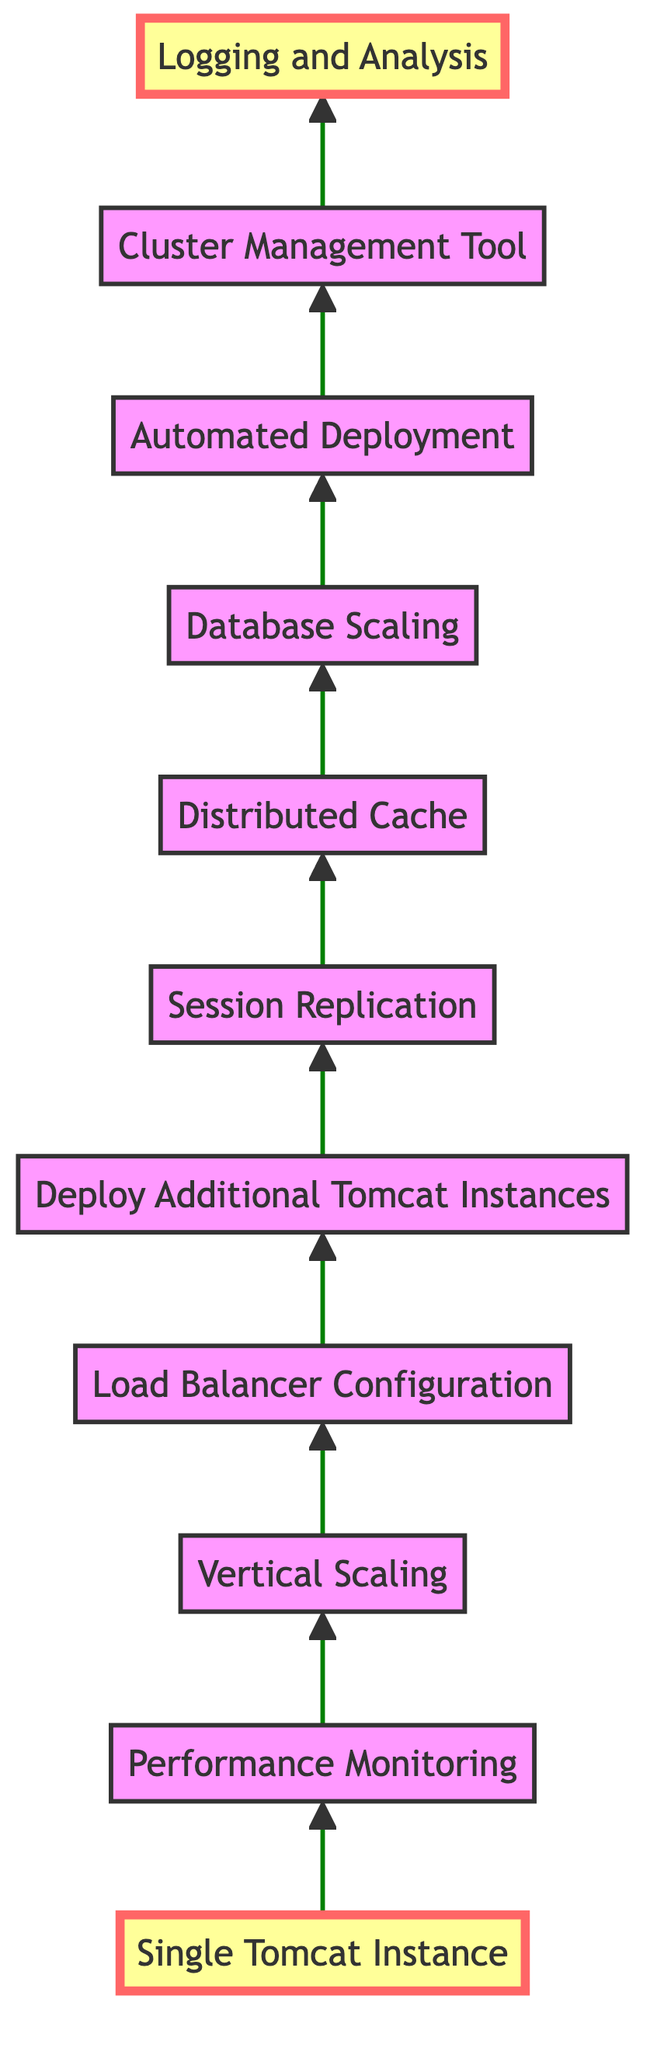What's the first step in scaling a Tomcat server? The diagram starts with a single instance, which is labeled as "Single Tomcat Instance." This is the foundation from where scaling begins.
Answer: Single Tomcat Instance How many nodes are in the diagram? The diagram contains a total of eleven nodes, each representing a step in the scaling process from a single Tomcat instance to a clustered environment.
Answer: Eleven What is the last step in the scaling process? The last node at the top of the diagram is "Logging and Analysis," which is the final step after implementing all other scaling measures.
Answer: Logging and Analysis How does "Load Balancer Configuration" relate to "Deploy Additional Tomcat Instances"? The diagram shows a direct progression from "Load Balancer Configuration" to "Deploy Additional Tomcat Instances," indicating that configuring a load balancer is necessary before deploying additional instances to handle distributed traffic.
Answer: It is a prerequisite Which step emphasizes enhancing the server's hardware? The node labeled "Vertical Scaling" is specifically aimed at enhancing the server’s hardware capabilities to manage larger workloads effectively.
Answer: Vertical Scaling What step follows "Distributing Cache"? After "Distributed Cache," the next step according to the flow of the diagram is "Database Scaling," indicating that data management is prioritized after implementing a caching system.
Answer: Database Scaling What monitoring tools are suggested in the diagram for tracking performance? The "Performance Monitoring" node recommends implementing tools such as JMX or Prometheus for tracking performance metrics of the Tomcat server.
Answer: JMX or Prometheus How is session management handled between servers? The diagram indicates that "Session Replication" is utilized to synchronize user sessions across different Tomcat servers, ensuring sessions are managed consistently even when multiple instances are in use.
Answer: Session Replication What is the purpose of using a cluster management tool? The node "Cluster Management Tool" integrates tools like Kubernetes or Docker Swarm for improved orchestration, scaling, and management in the clustered environment.
Answer: Improved orchestration and management 